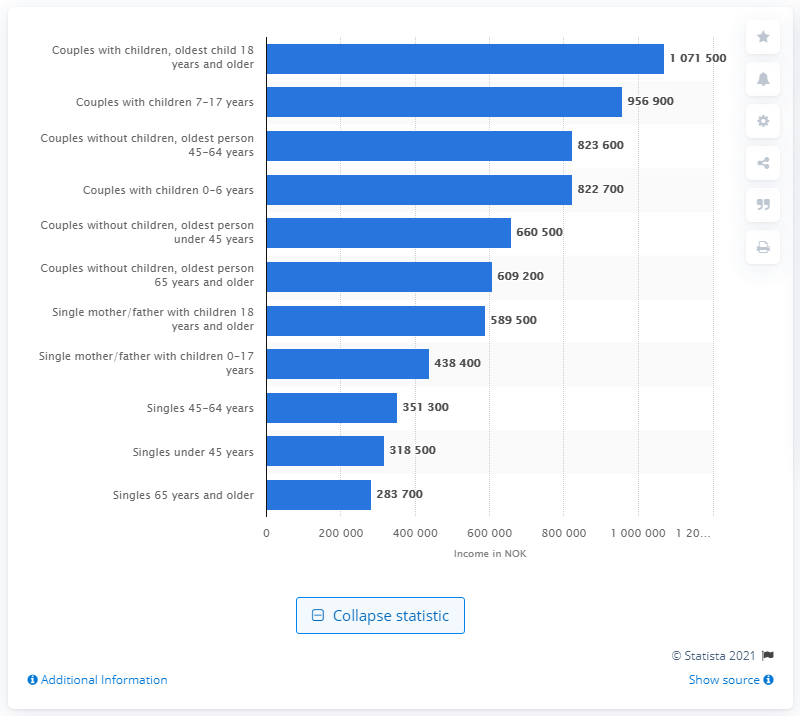Outline some significant characteristics in this image. The median income for a single mother or father with children until the age of 17 was approximately 438,400. 